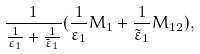<formula> <loc_0><loc_0><loc_500><loc_500>\frac { 1 } { \frac { 1 } { \varepsilon _ { 1 } } + \frac { 1 } { \tilde { \varepsilon } _ { 1 } } } ( \frac { 1 } { \varepsilon _ { 1 } } M _ { 1 } + \frac { 1 } { \tilde { \varepsilon } _ { 1 } } M _ { 1 2 } ) ,</formula> 